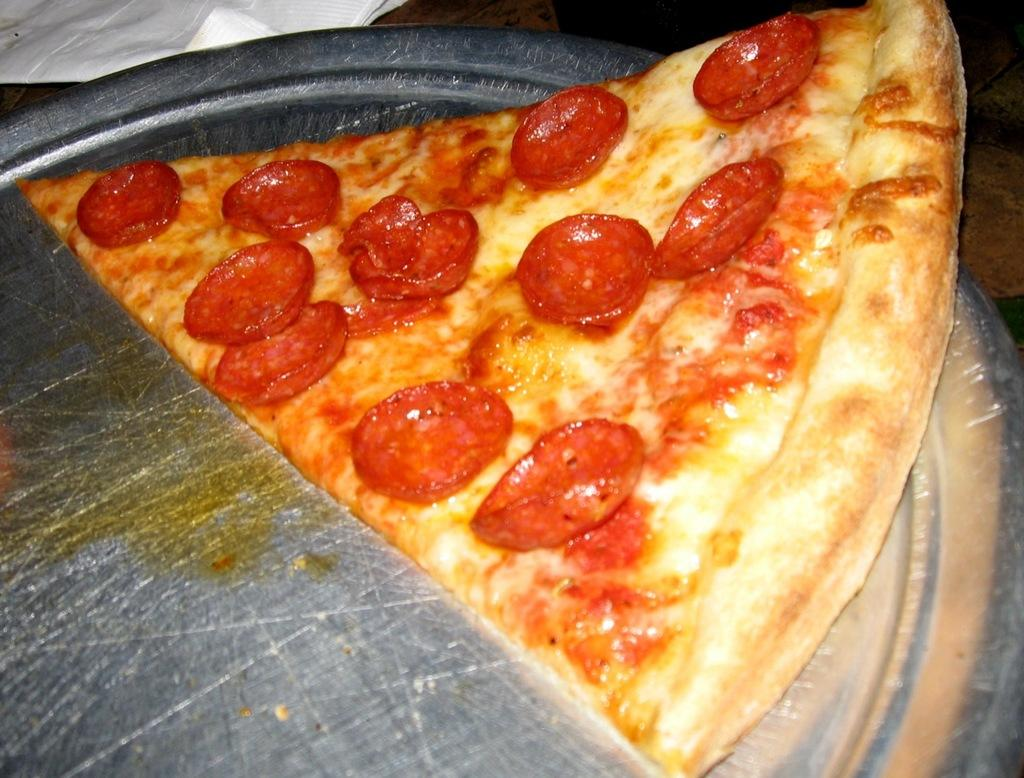What is on the plate in the image? There is pizza on the plate. Can you describe the main food item in the image? The main food item in the image is pizza. What type of property is visible in the image? There is no property visible in the image; it only features a plate with pizza. What is the stove used for in the image? There is no stove present in the image. 